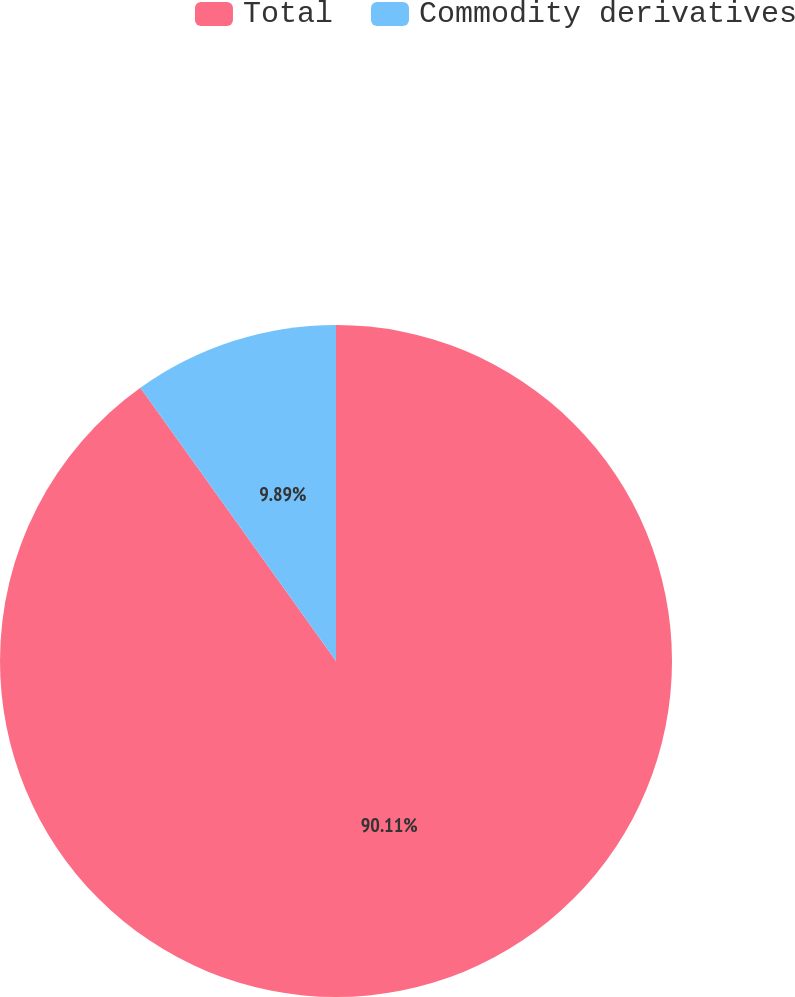<chart> <loc_0><loc_0><loc_500><loc_500><pie_chart><fcel>Total<fcel>Commodity derivatives<nl><fcel>90.11%<fcel>9.89%<nl></chart> 